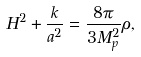Convert formula to latex. <formula><loc_0><loc_0><loc_500><loc_500>H ^ { 2 } + \frac { k } { a ^ { 2 } } = \frac { 8 \pi } { 3 M _ { p } ^ { 2 } } \rho ,</formula> 